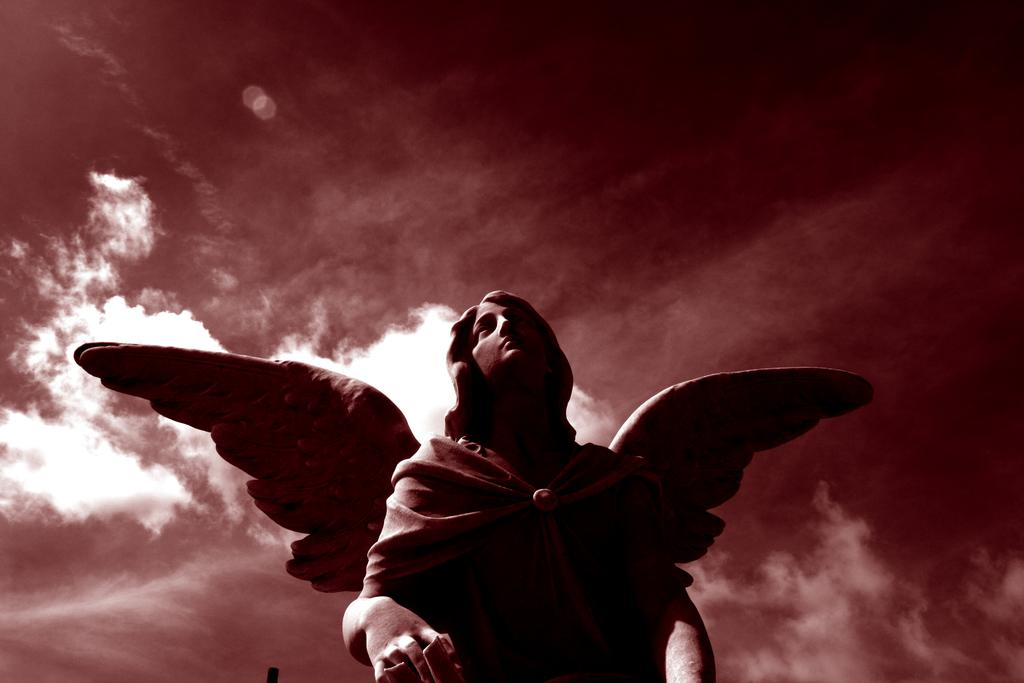What is the main subject of the image? The main subject of the image is a statue of a person. What distinguishing feature does the statue have? The statue has wings. What can be seen in the background of the image? The background of the image includes the sky. What is the condition of the sky in the image? There are clouds in the sky. How many cats are sitting on the statue in the image? There are no cats present in the image; it features a statue of a person with wings. What type of brush is being used by the carpenter in the image? There is no carpenter or brush present in the image; it only features a statue with wings and a sky background. 